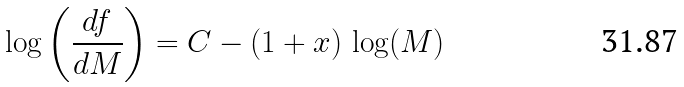<formula> <loc_0><loc_0><loc_500><loc_500>\log \left ( \frac { d f } { d M } \right ) = C - ( 1 + x ) \, \log ( M )</formula> 